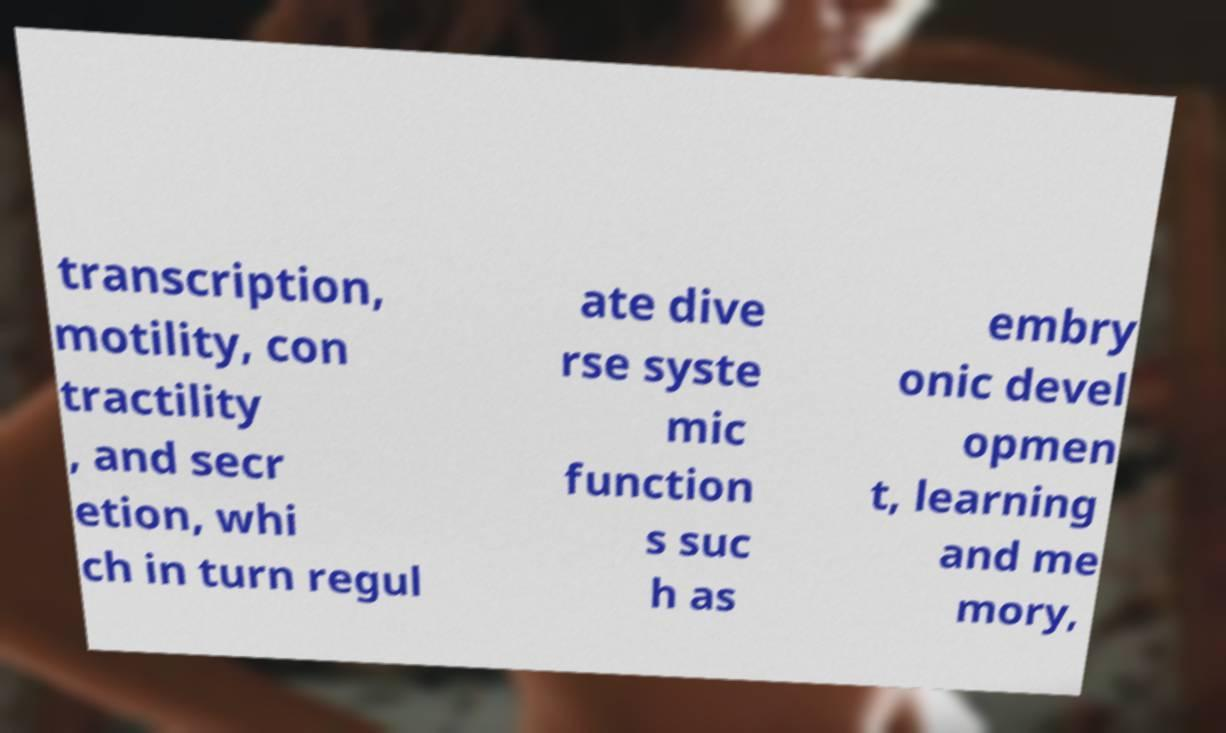Can you accurately transcribe the text from the provided image for me? transcription, motility, con tractility , and secr etion, whi ch in turn regul ate dive rse syste mic function s suc h as embry onic devel opmen t, learning and me mory, 